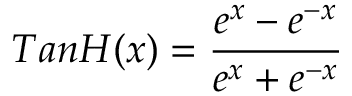<formula> <loc_0><loc_0><loc_500><loc_500>T a n H ( x ) = \frac { e ^ { x } - e ^ { - x } } { e ^ { x } + e ^ { - x } }</formula> 